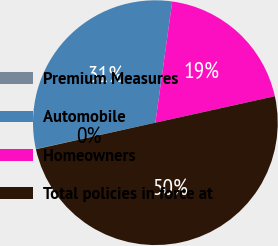Convert chart to OTSL. <chart><loc_0><loc_0><loc_500><loc_500><pie_chart><fcel>Premium Measures<fcel>Automobile<fcel>Homeowners<fcel>Total policies in force at<nl><fcel>0.03%<fcel>30.66%<fcel>19.33%<fcel>49.99%<nl></chart> 